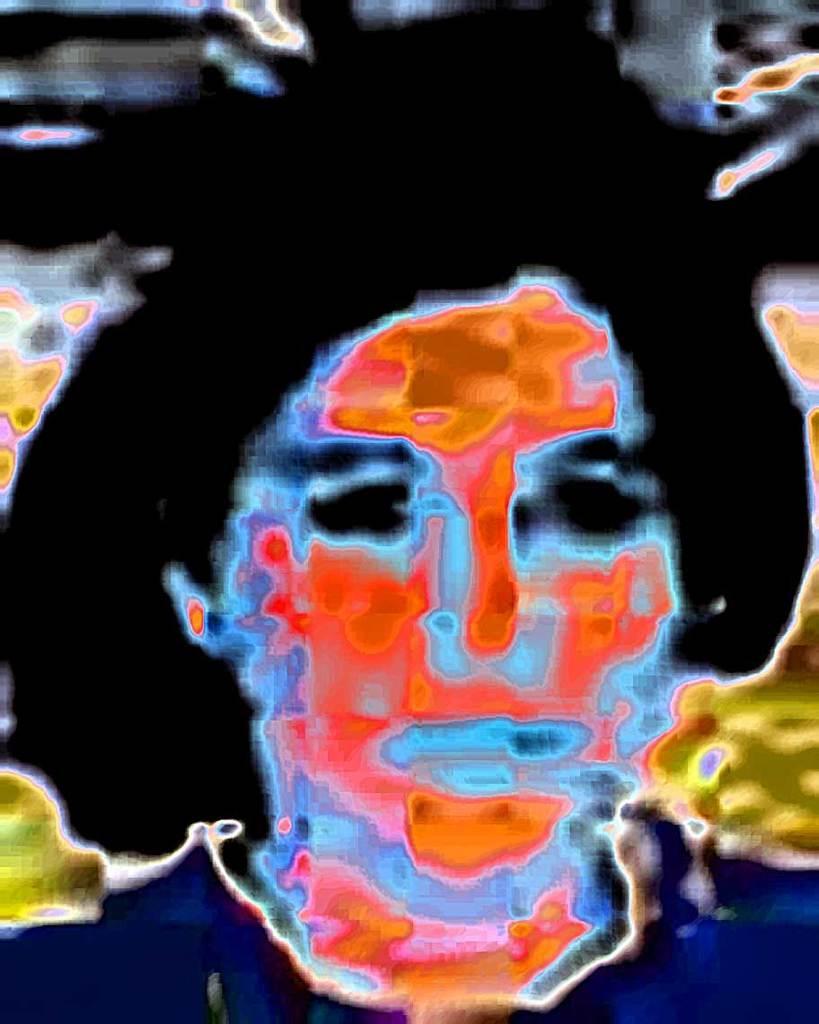How would you summarize this image in a sentence or two? It is an edited image. In this image we can see some person. 